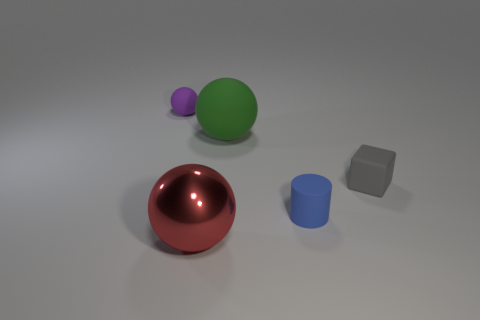Can you tell me how the lighting in the scene affects the appearance of objects? Certainly! The soft and diffused lighting in the image creates gentle shadows and subtle highlights on the objects, accentuating their shapes and textures without causing harsh reflections. It provides a calm and neutral environment that nicely presents each object's intrinsic color and material properties. 